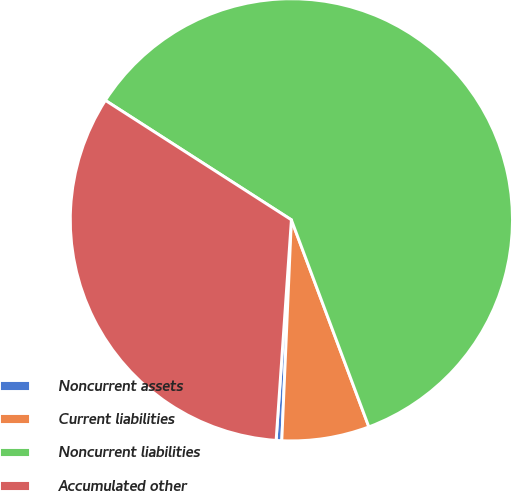Convert chart to OTSL. <chart><loc_0><loc_0><loc_500><loc_500><pie_chart><fcel>Noncurrent assets<fcel>Current liabilities<fcel>Noncurrent liabilities<fcel>Accumulated other<nl><fcel>0.41%<fcel>6.39%<fcel>60.21%<fcel>32.98%<nl></chart> 